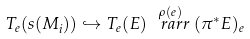Convert formula to latex. <formula><loc_0><loc_0><loc_500><loc_500>T _ { e } ( s ( M _ { i } ) ) \hookrightarrow T _ { e } ( E ) \stackrel { \rho ( e ) } { \ r a r r } ( \pi ^ { \ast } E ) _ { e }</formula> 